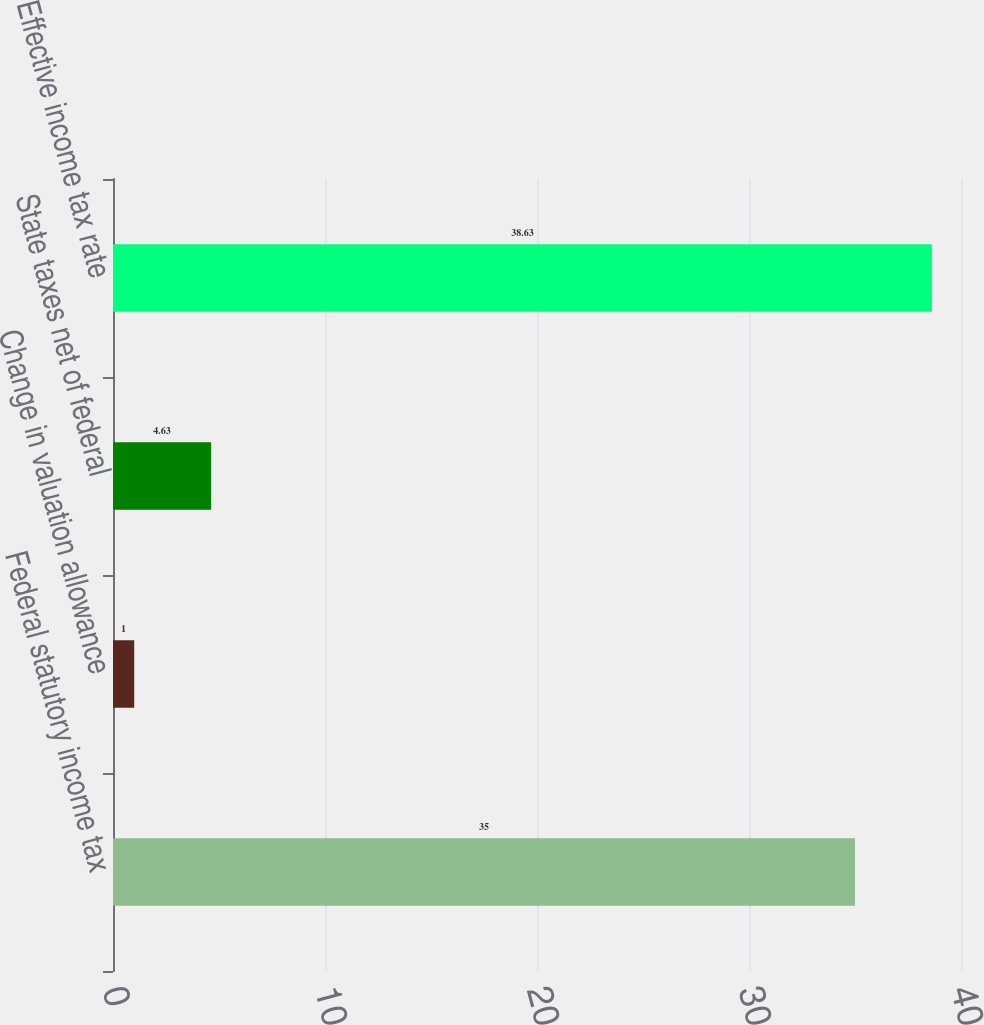Convert chart. <chart><loc_0><loc_0><loc_500><loc_500><bar_chart><fcel>Federal statutory income tax<fcel>Change in valuation allowance<fcel>State taxes net of federal<fcel>Effective income tax rate<nl><fcel>35<fcel>1<fcel>4.63<fcel>38.63<nl></chart> 